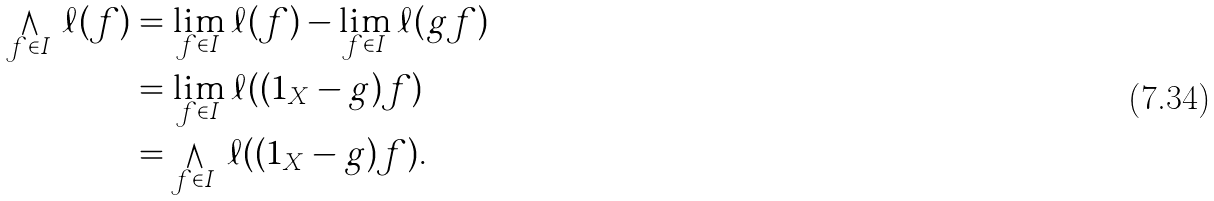Convert formula to latex. <formula><loc_0><loc_0><loc_500><loc_500>\bigwedge _ { f \in I } \, \ell ( f ) & = \lim _ { f \in I } \ell ( f ) - \lim _ { f \in I } \ell ( g f ) \\ & = \lim _ { f \in I } \ell ( ( 1 _ { X } - g ) f ) \\ & = \bigwedge _ { f \in I } \, \ell ( ( 1 _ { X } - g ) f ) .</formula> 